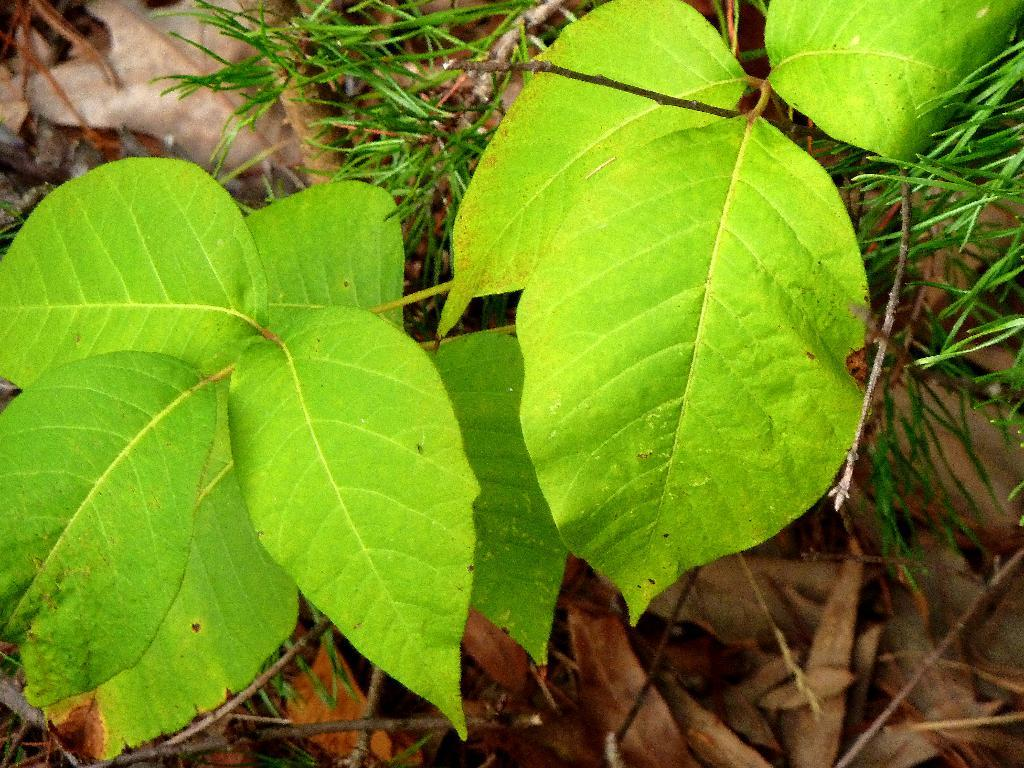What type of living organisms can be seen in the image? Plants can be seen in the image. What part of the plants is visible in the image? Leaves are visible in the image. What type of car is parked next to the plants in the image? There is no car present in the image; it only features plants and leaves. 